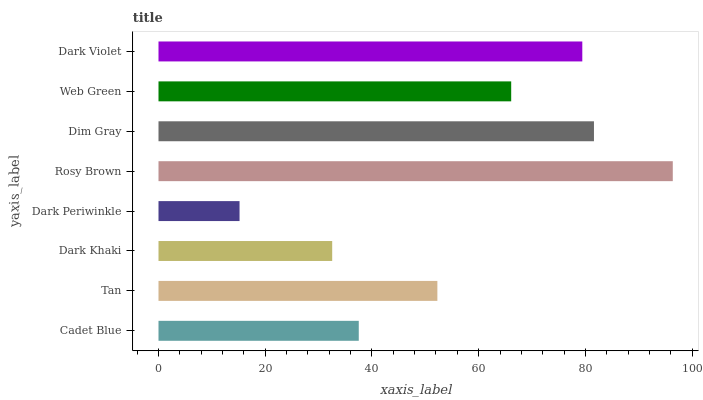Is Dark Periwinkle the minimum?
Answer yes or no. Yes. Is Rosy Brown the maximum?
Answer yes or no. Yes. Is Tan the minimum?
Answer yes or no. No. Is Tan the maximum?
Answer yes or no. No. Is Tan greater than Cadet Blue?
Answer yes or no. Yes. Is Cadet Blue less than Tan?
Answer yes or no. Yes. Is Cadet Blue greater than Tan?
Answer yes or no. No. Is Tan less than Cadet Blue?
Answer yes or no. No. Is Web Green the high median?
Answer yes or no. Yes. Is Tan the low median?
Answer yes or no. Yes. Is Dim Gray the high median?
Answer yes or no. No. Is Web Green the low median?
Answer yes or no. No. 